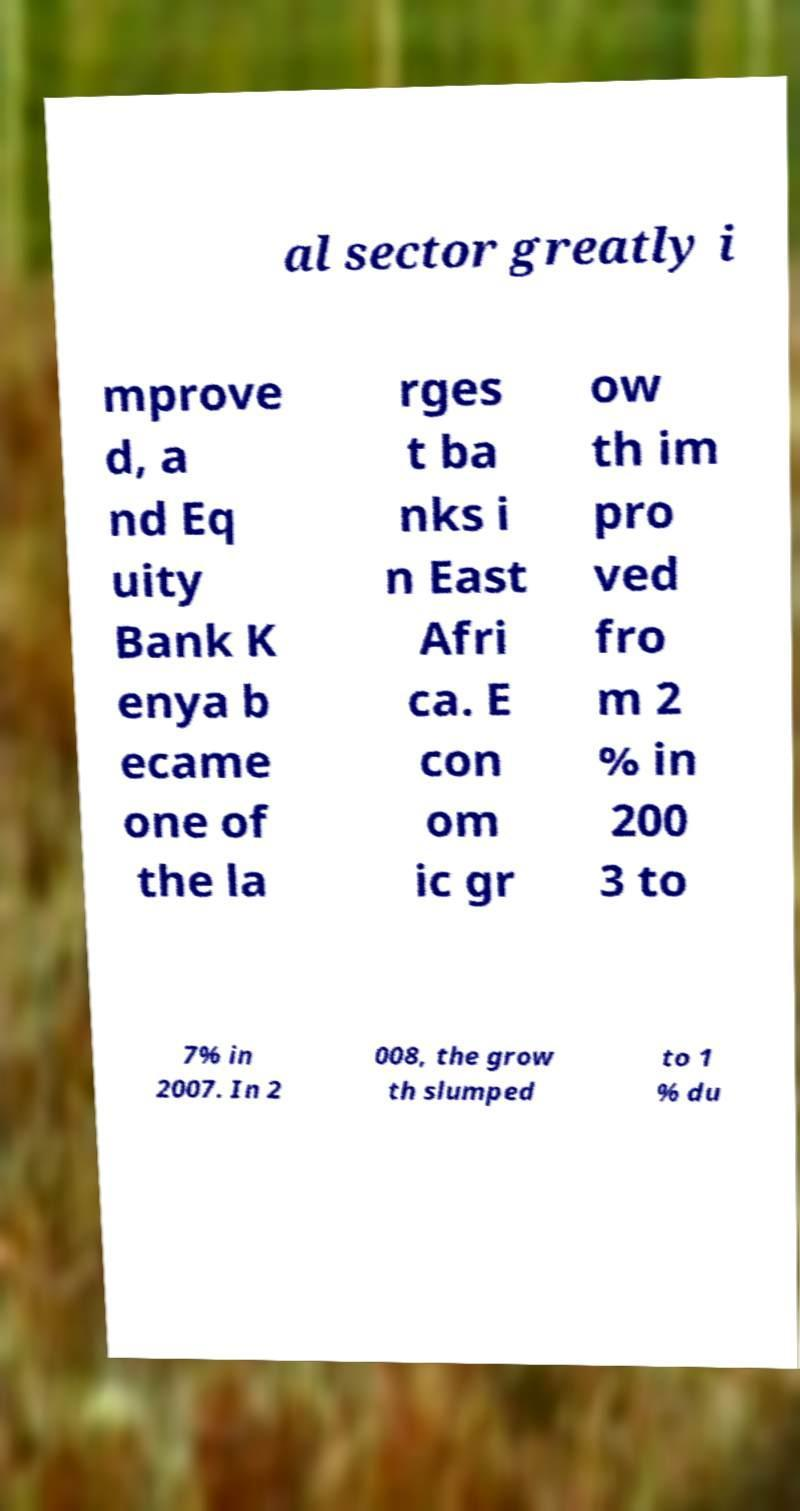Please read and relay the text visible in this image. What does it say? al sector greatly i mprove d, a nd Eq uity Bank K enya b ecame one of the la rges t ba nks i n East Afri ca. E con om ic gr ow th im pro ved fro m 2 % in 200 3 to 7% in 2007. In 2 008, the grow th slumped to 1 % du 